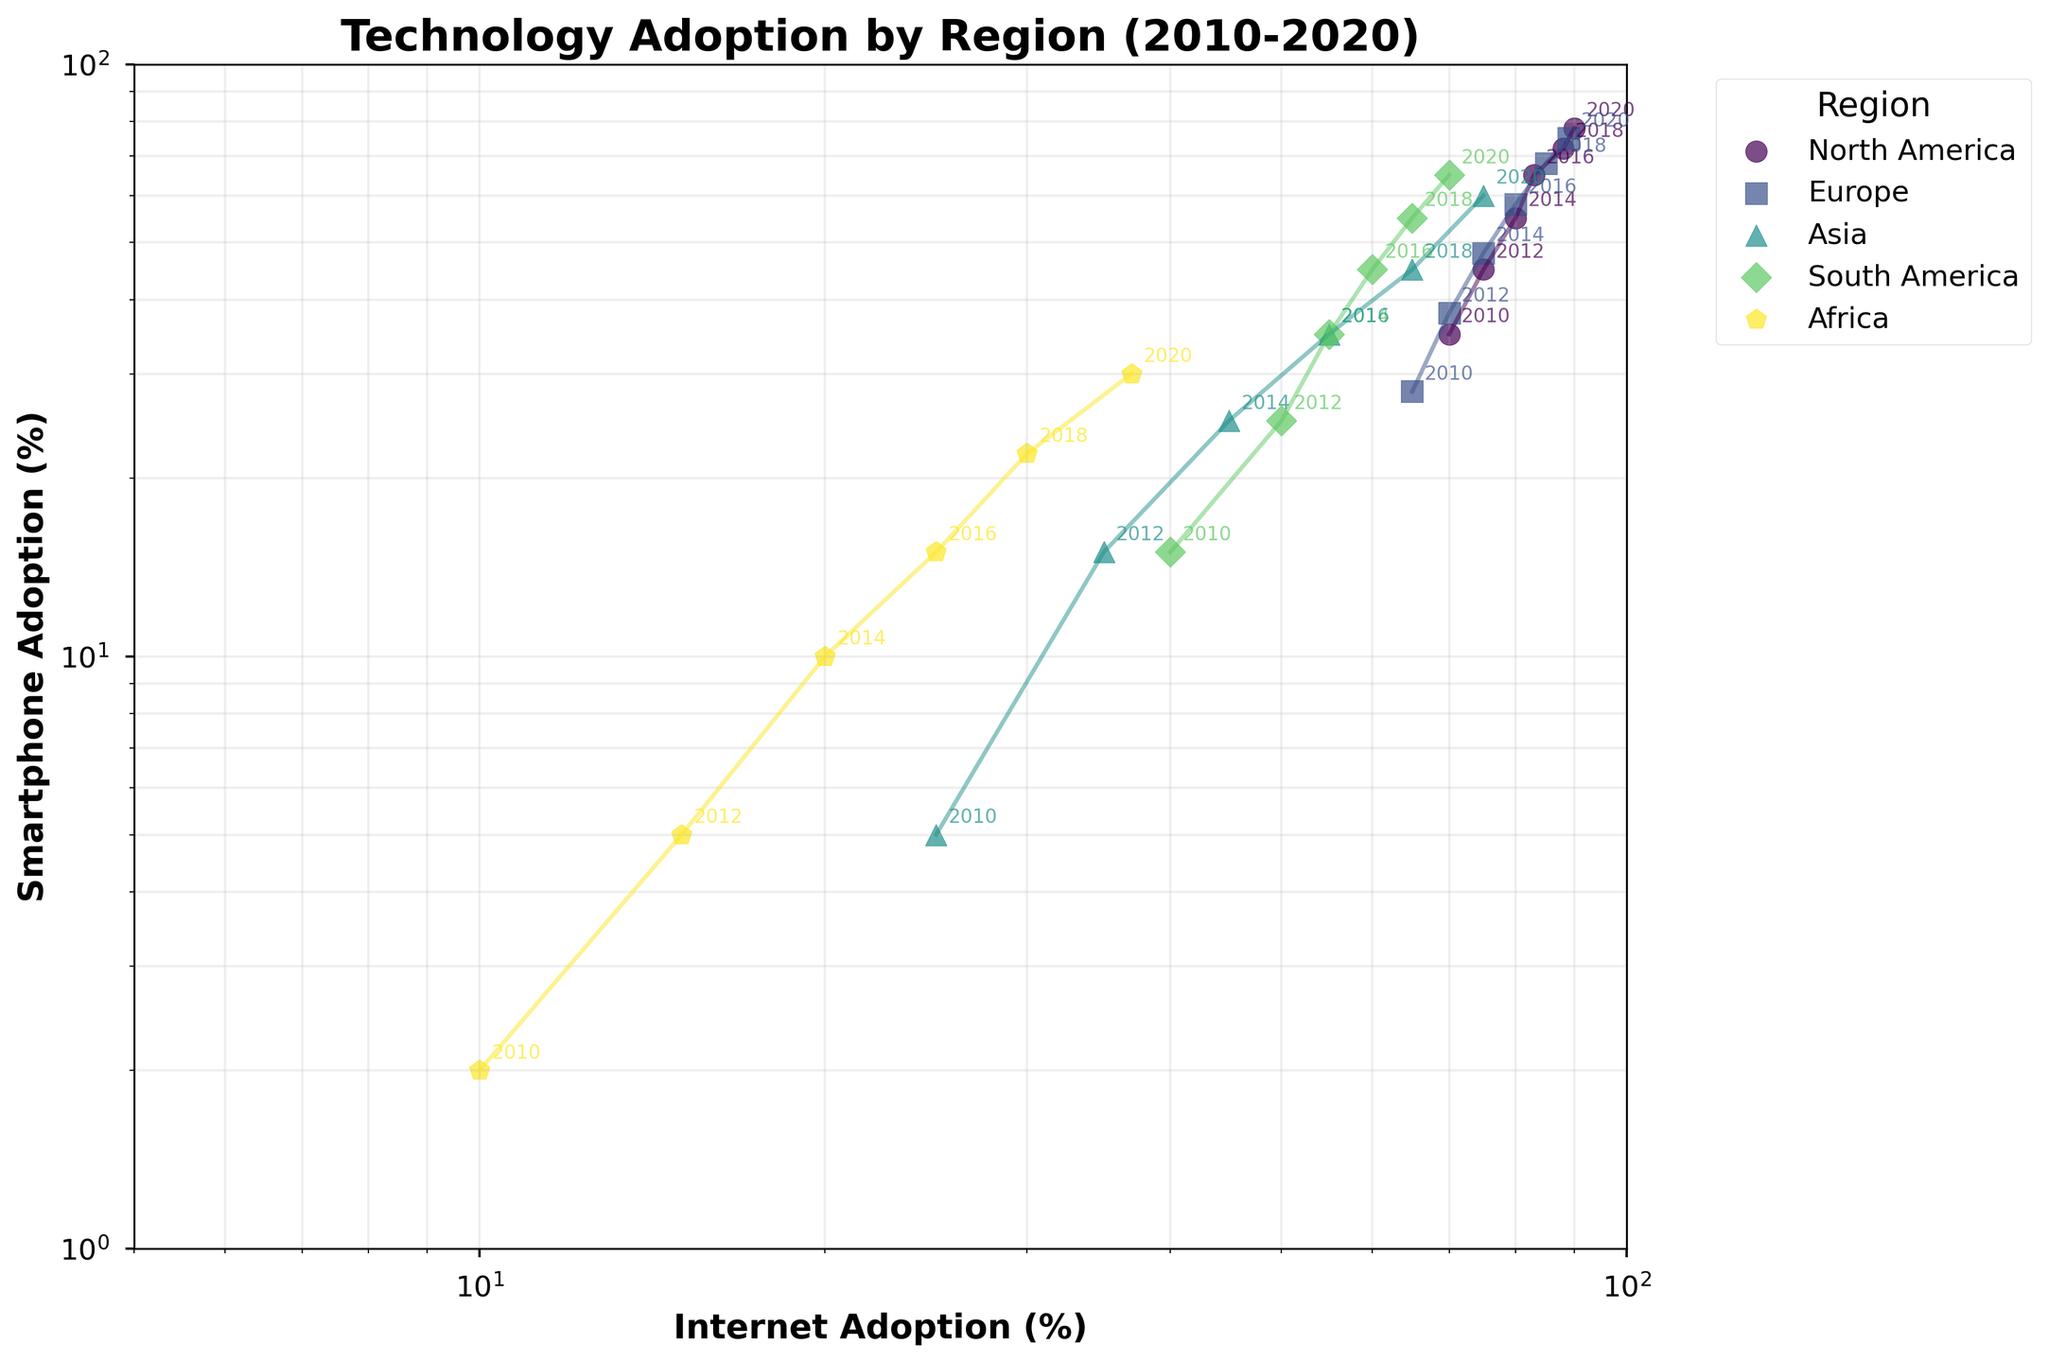Which region had the highest smartphone adoption in 2010? Inspect the 2010 data points; North America has the highest smartphone adoption point at approximately 35%.
Answer: North America What's the title of the plot? Look at the top of the plot, where the title is usually located. It reads "Technology Adoption by Region (2010-2020)".
Answer: Technology Adoption by Region (2010-2020) Compare the smartphone adoption in Europe and Asia in 2016. Which region had higher adoption? Look at the 2016 data points for Europe and Asia; Europe shows around 58%, while Asia has about 35%. Therefore, Europe had higher smartphone adoption in 2016.
Answer: Europe How many regions have data points annotated for the year 2020? Check the annotations on the plot for the year "2020". There are five data points annotated, indicating five regions.
Answer: 5 By how much did smartphone adoption increase in Africa from 2010 to 2020? Look at the smartphone adoption rates in Africa for 2010 and 2020. It increased from approximately 2% in 2010 to 30% in 2020. Therefore, the increase is 30% - 2% = 28%.
Answer: 28% Which region shows the steepest growth in smartphone adoption on the log scale? Inspect the slope of the lines connecting the data points. Asia shows the steepest growth as the smartphone adoption rate increased significantly on the log scale.
Answer: Asia What can you say about the comparative growth trends of internet and smartphone adoption in South America from 2010 to 2020? Observing the line connecting South America's data points, both internet and smartphone adoption rose consistently. Internet adoption went from 40% to 70%, while smartphone adoption increased from 15% to 65%. Both exhibit steady growth trends.
Answer: Both showed steady growth What is the log-scaled range of internet adoption shown on the x-axis? The x-axis (Internet Adoption) on the log scale ranges from 5% to 100%, as observed from the axis limits.
Answer: 5% to 100% Find the year in which smartphone adoption in North America surpassed 70%. Check the North America data points. In 2018, the smartphone adoption rate surpasses 70%, reaching about 72%.
Answer: 2018 